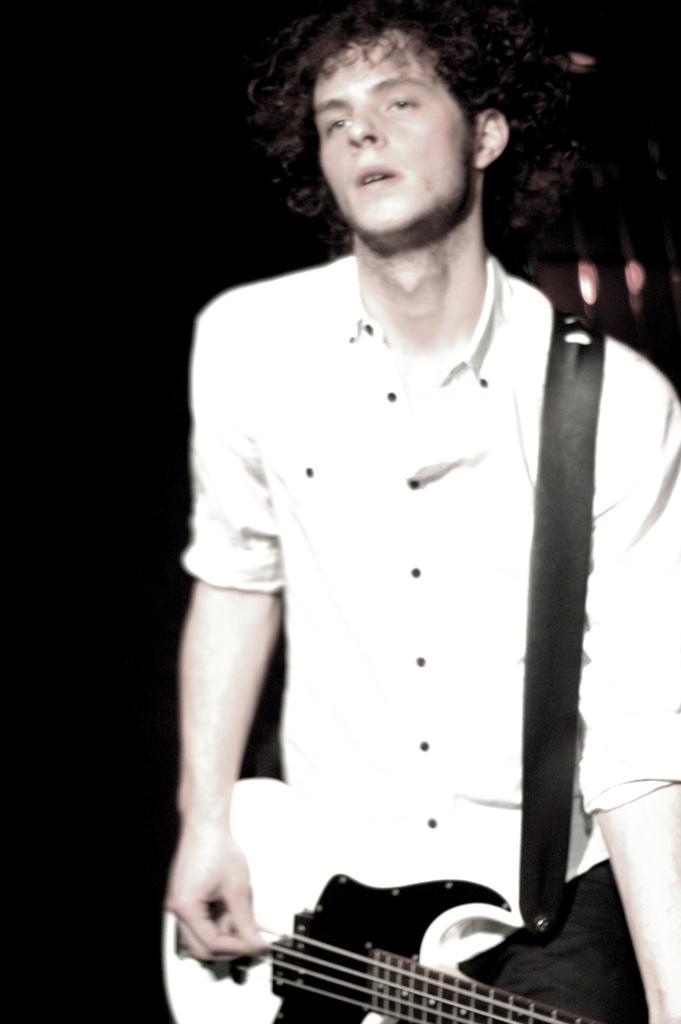Could you give a brief overview of what you see in this image? Background is very dark. We can see one man wearing white color shirt playing guitar. His hair is curly. 